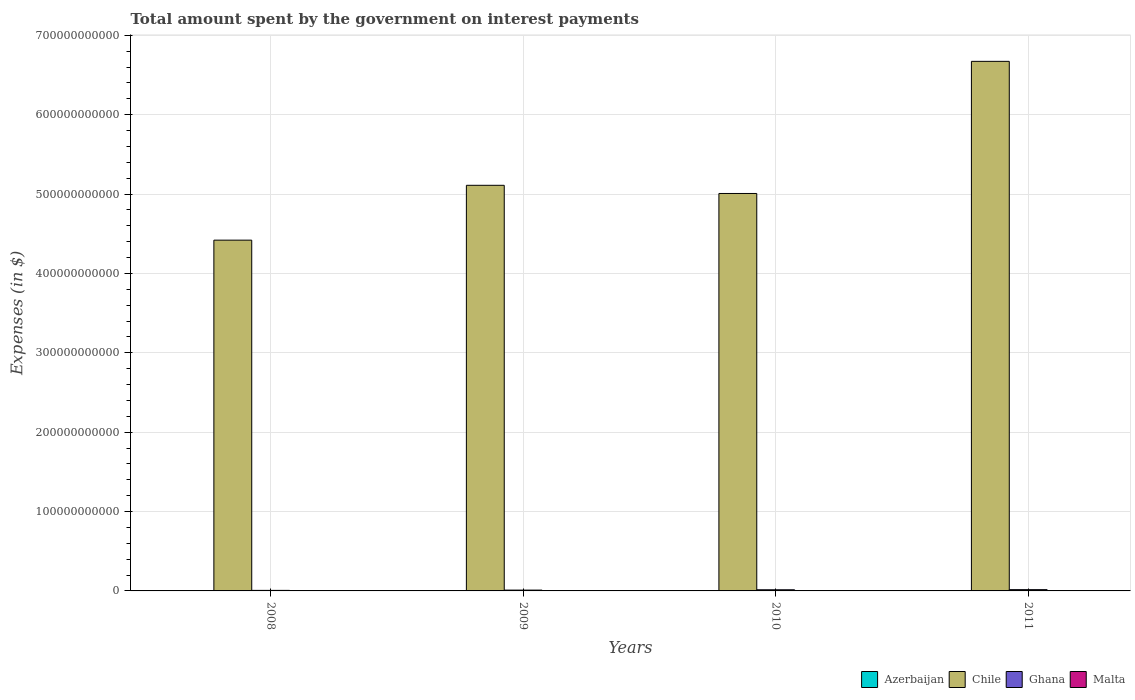How many different coloured bars are there?
Provide a succinct answer. 4. How many groups of bars are there?
Your answer should be very brief. 4. How many bars are there on the 2nd tick from the right?
Offer a terse response. 4. What is the amount spent on interest payments by the government in Chile in 2010?
Your answer should be compact. 5.01e+11. Across all years, what is the maximum amount spent on interest payments by the government in Ghana?
Your answer should be very brief. 1.61e+09. Across all years, what is the minimum amount spent on interest payments by the government in Ghana?
Offer a terse response. 6.79e+08. What is the total amount spent on interest payments by the government in Azerbaijan in the graph?
Offer a very short reply. 3.20e+08. What is the difference between the amount spent on interest payments by the government in Ghana in 2008 and that in 2009?
Make the answer very short. -3.53e+08. What is the difference between the amount spent on interest payments by the government in Ghana in 2008 and the amount spent on interest payments by the government in Malta in 2009?
Keep it short and to the point. 4.96e+08. What is the average amount spent on interest payments by the government in Malta per year?
Offer a terse response. 1.89e+08. In the year 2008, what is the difference between the amount spent on interest payments by the government in Chile and amount spent on interest payments by the government in Malta?
Your answer should be compact. 4.42e+11. In how many years, is the amount spent on interest payments by the government in Azerbaijan greater than 240000000000 $?
Offer a very short reply. 0. What is the ratio of the amount spent on interest payments by the government in Azerbaijan in 2008 to that in 2011?
Provide a succinct answer. 0.19. Is the difference between the amount spent on interest payments by the government in Chile in 2008 and 2011 greater than the difference between the amount spent on interest payments by the government in Malta in 2008 and 2011?
Provide a short and direct response. No. What is the difference between the highest and the second highest amount spent on interest payments by the government in Ghana?
Provide a succinct answer. 1.72e+08. What is the difference between the highest and the lowest amount spent on interest payments by the government in Malta?
Keep it short and to the point. 1.75e+07. What does the 2nd bar from the right in 2011 represents?
Your answer should be compact. Ghana. How many bars are there?
Your answer should be compact. 16. Are all the bars in the graph horizontal?
Your answer should be very brief. No. How many years are there in the graph?
Offer a terse response. 4. What is the difference between two consecutive major ticks on the Y-axis?
Your response must be concise. 1.00e+11. Does the graph contain grids?
Provide a succinct answer. Yes. Where does the legend appear in the graph?
Ensure brevity in your answer.  Bottom right. What is the title of the graph?
Your response must be concise. Total amount spent by the government on interest payments. Does "Lao PDR" appear as one of the legend labels in the graph?
Ensure brevity in your answer.  No. What is the label or title of the Y-axis?
Ensure brevity in your answer.  Expenses (in $). What is the Expenses (in $) of Azerbaijan in 2008?
Your answer should be very brief. 3.27e+07. What is the Expenses (in $) of Chile in 2008?
Offer a very short reply. 4.42e+11. What is the Expenses (in $) in Ghana in 2008?
Give a very brief answer. 6.79e+08. What is the Expenses (in $) in Malta in 2008?
Make the answer very short. 1.88e+08. What is the Expenses (in $) in Azerbaijan in 2009?
Offer a very short reply. 7.87e+07. What is the Expenses (in $) of Chile in 2009?
Offer a very short reply. 5.11e+11. What is the Expenses (in $) of Ghana in 2009?
Your answer should be compact. 1.03e+09. What is the Expenses (in $) in Malta in 2009?
Provide a short and direct response. 1.83e+08. What is the Expenses (in $) of Azerbaijan in 2010?
Keep it short and to the point. 3.95e+07. What is the Expenses (in $) of Chile in 2010?
Provide a short and direct response. 5.01e+11. What is the Expenses (in $) of Ghana in 2010?
Keep it short and to the point. 1.44e+09. What is the Expenses (in $) of Malta in 2010?
Your response must be concise. 1.86e+08. What is the Expenses (in $) of Azerbaijan in 2011?
Offer a very short reply. 1.70e+08. What is the Expenses (in $) of Chile in 2011?
Your answer should be compact. 6.67e+11. What is the Expenses (in $) of Ghana in 2011?
Your answer should be very brief. 1.61e+09. What is the Expenses (in $) of Malta in 2011?
Provide a succinct answer. 2.01e+08. Across all years, what is the maximum Expenses (in $) in Azerbaijan?
Keep it short and to the point. 1.70e+08. Across all years, what is the maximum Expenses (in $) in Chile?
Your response must be concise. 6.67e+11. Across all years, what is the maximum Expenses (in $) of Ghana?
Your answer should be very brief. 1.61e+09. Across all years, what is the maximum Expenses (in $) of Malta?
Make the answer very short. 2.01e+08. Across all years, what is the minimum Expenses (in $) in Azerbaijan?
Provide a succinct answer. 3.27e+07. Across all years, what is the minimum Expenses (in $) in Chile?
Your answer should be very brief. 4.42e+11. Across all years, what is the minimum Expenses (in $) of Ghana?
Make the answer very short. 6.79e+08. Across all years, what is the minimum Expenses (in $) of Malta?
Keep it short and to the point. 1.83e+08. What is the total Expenses (in $) in Azerbaijan in the graph?
Give a very brief answer. 3.20e+08. What is the total Expenses (in $) in Chile in the graph?
Offer a terse response. 2.12e+12. What is the total Expenses (in $) of Ghana in the graph?
Make the answer very short. 4.76e+09. What is the total Expenses (in $) in Malta in the graph?
Provide a succinct answer. 7.58e+08. What is the difference between the Expenses (in $) of Azerbaijan in 2008 and that in 2009?
Make the answer very short. -4.60e+07. What is the difference between the Expenses (in $) of Chile in 2008 and that in 2009?
Your answer should be compact. -6.91e+1. What is the difference between the Expenses (in $) of Ghana in 2008 and that in 2009?
Provide a succinct answer. -3.53e+08. What is the difference between the Expenses (in $) in Malta in 2008 and that in 2009?
Give a very brief answer. 4.39e+06. What is the difference between the Expenses (in $) of Azerbaijan in 2008 and that in 2010?
Provide a succinct answer. -6.80e+06. What is the difference between the Expenses (in $) of Chile in 2008 and that in 2010?
Provide a succinct answer. -5.88e+1. What is the difference between the Expenses (in $) of Ghana in 2008 and that in 2010?
Provide a short and direct response. -7.60e+08. What is the difference between the Expenses (in $) of Malta in 2008 and that in 2010?
Ensure brevity in your answer.  1.37e+06. What is the difference between the Expenses (in $) in Azerbaijan in 2008 and that in 2011?
Your response must be concise. -1.37e+08. What is the difference between the Expenses (in $) of Chile in 2008 and that in 2011?
Provide a short and direct response. -2.25e+11. What is the difference between the Expenses (in $) of Ghana in 2008 and that in 2011?
Make the answer very short. -9.32e+08. What is the difference between the Expenses (in $) in Malta in 2008 and that in 2011?
Your response must be concise. -1.31e+07. What is the difference between the Expenses (in $) in Azerbaijan in 2009 and that in 2010?
Offer a very short reply. 3.92e+07. What is the difference between the Expenses (in $) in Chile in 2009 and that in 2010?
Your answer should be compact. 1.03e+1. What is the difference between the Expenses (in $) in Ghana in 2009 and that in 2010?
Ensure brevity in your answer.  -4.07e+08. What is the difference between the Expenses (in $) in Malta in 2009 and that in 2010?
Ensure brevity in your answer.  -3.02e+06. What is the difference between the Expenses (in $) of Azerbaijan in 2009 and that in 2011?
Your answer should be very brief. -9.09e+07. What is the difference between the Expenses (in $) in Chile in 2009 and that in 2011?
Your answer should be very brief. -1.56e+11. What is the difference between the Expenses (in $) in Ghana in 2009 and that in 2011?
Make the answer very short. -5.79e+08. What is the difference between the Expenses (in $) in Malta in 2009 and that in 2011?
Offer a terse response. -1.75e+07. What is the difference between the Expenses (in $) in Azerbaijan in 2010 and that in 2011?
Keep it short and to the point. -1.30e+08. What is the difference between the Expenses (in $) in Chile in 2010 and that in 2011?
Keep it short and to the point. -1.66e+11. What is the difference between the Expenses (in $) of Ghana in 2010 and that in 2011?
Give a very brief answer. -1.72e+08. What is the difference between the Expenses (in $) of Malta in 2010 and that in 2011?
Provide a short and direct response. -1.45e+07. What is the difference between the Expenses (in $) in Azerbaijan in 2008 and the Expenses (in $) in Chile in 2009?
Provide a short and direct response. -5.11e+11. What is the difference between the Expenses (in $) of Azerbaijan in 2008 and the Expenses (in $) of Ghana in 2009?
Provide a succinct answer. -1.00e+09. What is the difference between the Expenses (in $) in Azerbaijan in 2008 and the Expenses (in $) in Malta in 2009?
Your answer should be very brief. -1.51e+08. What is the difference between the Expenses (in $) of Chile in 2008 and the Expenses (in $) of Ghana in 2009?
Provide a short and direct response. 4.41e+11. What is the difference between the Expenses (in $) in Chile in 2008 and the Expenses (in $) in Malta in 2009?
Offer a terse response. 4.42e+11. What is the difference between the Expenses (in $) of Ghana in 2008 and the Expenses (in $) of Malta in 2009?
Provide a succinct answer. 4.96e+08. What is the difference between the Expenses (in $) of Azerbaijan in 2008 and the Expenses (in $) of Chile in 2010?
Offer a terse response. -5.01e+11. What is the difference between the Expenses (in $) of Azerbaijan in 2008 and the Expenses (in $) of Ghana in 2010?
Give a very brief answer. -1.41e+09. What is the difference between the Expenses (in $) in Azerbaijan in 2008 and the Expenses (in $) in Malta in 2010?
Provide a succinct answer. -1.54e+08. What is the difference between the Expenses (in $) of Chile in 2008 and the Expenses (in $) of Ghana in 2010?
Provide a short and direct response. 4.40e+11. What is the difference between the Expenses (in $) of Chile in 2008 and the Expenses (in $) of Malta in 2010?
Keep it short and to the point. 4.42e+11. What is the difference between the Expenses (in $) of Ghana in 2008 and the Expenses (in $) of Malta in 2010?
Your response must be concise. 4.93e+08. What is the difference between the Expenses (in $) of Azerbaijan in 2008 and the Expenses (in $) of Chile in 2011?
Your answer should be very brief. -6.67e+11. What is the difference between the Expenses (in $) of Azerbaijan in 2008 and the Expenses (in $) of Ghana in 2011?
Your response must be concise. -1.58e+09. What is the difference between the Expenses (in $) in Azerbaijan in 2008 and the Expenses (in $) in Malta in 2011?
Make the answer very short. -1.68e+08. What is the difference between the Expenses (in $) of Chile in 2008 and the Expenses (in $) of Ghana in 2011?
Keep it short and to the point. 4.40e+11. What is the difference between the Expenses (in $) of Chile in 2008 and the Expenses (in $) of Malta in 2011?
Your answer should be very brief. 4.42e+11. What is the difference between the Expenses (in $) of Ghana in 2008 and the Expenses (in $) of Malta in 2011?
Provide a short and direct response. 4.78e+08. What is the difference between the Expenses (in $) of Azerbaijan in 2009 and the Expenses (in $) of Chile in 2010?
Keep it short and to the point. -5.01e+11. What is the difference between the Expenses (in $) of Azerbaijan in 2009 and the Expenses (in $) of Ghana in 2010?
Keep it short and to the point. -1.36e+09. What is the difference between the Expenses (in $) in Azerbaijan in 2009 and the Expenses (in $) in Malta in 2010?
Your response must be concise. -1.08e+08. What is the difference between the Expenses (in $) of Chile in 2009 and the Expenses (in $) of Ghana in 2010?
Make the answer very short. 5.10e+11. What is the difference between the Expenses (in $) of Chile in 2009 and the Expenses (in $) of Malta in 2010?
Give a very brief answer. 5.11e+11. What is the difference between the Expenses (in $) in Ghana in 2009 and the Expenses (in $) in Malta in 2010?
Ensure brevity in your answer.  8.46e+08. What is the difference between the Expenses (in $) of Azerbaijan in 2009 and the Expenses (in $) of Chile in 2011?
Your answer should be very brief. -6.67e+11. What is the difference between the Expenses (in $) in Azerbaijan in 2009 and the Expenses (in $) in Ghana in 2011?
Ensure brevity in your answer.  -1.53e+09. What is the difference between the Expenses (in $) of Azerbaijan in 2009 and the Expenses (in $) of Malta in 2011?
Your response must be concise. -1.22e+08. What is the difference between the Expenses (in $) of Chile in 2009 and the Expenses (in $) of Ghana in 2011?
Your answer should be very brief. 5.09e+11. What is the difference between the Expenses (in $) in Chile in 2009 and the Expenses (in $) in Malta in 2011?
Your response must be concise. 5.11e+11. What is the difference between the Expenses (in $) in Ghana in 2009 and the Expenses (in $) in Malta in 2011?
Give a very brief answer. 8.32e+08. What is the difference between the Expenses (in $) of Azerbaijan in 2010 and the Expenses (in $) of Chile in 2011?
Give a very brief answer. -6.67e+11. What is the difference between the Expenses (in $) in Azerbaijan in 2010 and the Expenses (in $) in Ghana in 2011?
Offer a very short reply. -1.57e+09. What is the difference between the Expenses (in $) of Azerbaijan in 2010 and the Expenses (in $) of Malta in 2011?
Ensure brevity in your answer.  -1.61e+08. What is the difference between the Expenses (in $) of Chile in 2010 and the Expenses (in $) of Ghana in 2011?
Your answer should be compact. 4.99e+11. What is the difference between the Expenses (in $) in Chile in 2010 and the Expenses (in $) in Malta in 2011?
Provide a short and direct response. 5.01e+11. What is the difference between the Expenses (in $) in Ghana in 2010 and the Expenses (in $) in Malta in 2011?
Provide a succinct answer. 1.24e+09. What is the average Expenses (in $) of Azerbaijan per year?
Keep it short and to the point. 8.01e+07. What is the average Expenses (in $) in Chile per year?
Keep it short and to the point. 5.30e+11. What is the average Expenses (in $) in Ghana per year?
Your response must be concise. 1.19e+09. What is the average Expenses (in $) in Malta per year?
Provide a short and direct response. 1.89e+08. In the year 2008, what is the difference between the Expenses (in $) of Azerbaijan and Expenses (in $) of Chile?
Your response must be concise. -4.42e+11. In the year 2008, what is the difference between the Expenses (in $) of Azerbaijan and Expenses (in $) of Ghana?
Provide a succinct answer. -6.46e+08. In the year 2008, what is the difference between the Expenses (in $) in Azerbaijan and Expenses (in $) in Malta?
Offer a terse response. -1.55e+08. In the year 2008, what is the difference between the Expenses (in $) in Chile and Expenses (in $) in Ghana?
Your response must be concise. 4.41e+11. In the year 2008, what is the difference between the Expenses (in $) of Chile and Expenses (in $) of Malta?
Ensure brevity in your answer.  4.42e+11. In the year 2008, what is the difference between the Expenses (in $) in Ghana and Expenses (in $) in Malta?
Your answer should be very brief. 4.92e+08. In the year 2009, what is the difference between the Expenses (in $) of Azerbaijan and Expenses (in $) of Chile?
Your response must be concise. -5.11e+11. In the year 2009, what is the difference between the Expenses (in $) of Azerbaijan and Expenses (in $) of Ghana?
Give a very brief answer. -9.54e+08. In the year 2009, what is the difference between the Expenses (in $) in Azerbaijan and Expenses (in $) in Malta?
Your answer should be compact. -1.05e+08. In the year 2009, what is the difference between the Expenses (in $) of Chile and Expenses (in $) of Ghana?
Make the answer very short. 5.10e+11. In the year 2009, what is the difference between the Expenses (in $) in Chile and Expenses (in $) in Malta?
Give a very brief answer. 5.11e+11. In the year 2009, what is the difference between the Expenses (in $) of Ghana and Expenses (in $) of Malta?
Ensure brevity in your answer.  8.49e+08. In the year 2010, what is the difference between the Expenses (in $) in Azerbaijan and Expenses (in $) in Chile?
Offer a very short reply. -5.01e+11. In the year 2010, what is the difference between the Expenses (in $) of Azerbaijan and Expenses (in $) of Ghana?
Keep it short and to the point. -1.40e+09. In the year 2010, what is the difference between the Expenses (in $) in Azerbaijan and Expenses (in $) in Malta?
Your answer should be very brief. -1.47e+08. In the year 2010, what is the difference between the Expenses (in $) in Chile and Expenses (in $) in Ghana?
Keep it short and to the point. 4.99e+11. In the year 2010, what is the difference between the Expenses (in $) of Chile and Expenses (in $) of Malta?
Offer a very short reply. 5.01e+11. In the year 2010, what is the difference between the Expenses (in $) in Ghana and Expenses (in $) in Malta?
Keep it short and to the point. 1.25e+09. In the year 2011, what is the difference between the Expenses (in $) in Azerbaijan and Expenses (in $) in Chile?
Provide a succinct answer. -6.67e+11. In the year 2011, what is the difference between the Expenses (in $) in Azerbaijan and Expenses (in $) in Ghana?
Your answer should be compact. -1.44e+09. In the year 2011, what is the difference between the Expenses (in $) of Azerbaijan and Expenses (in $) of Malta?
Your answer should be very brief. -3.12e+07. In the year 2011, what is the difference between the Expenses (in $) in Chile and Expenses (in $) in Ghana?
Ensure brevity in your answer.  6.66e+11. In the year 2011, what is the difference between the Expenses (in $) in Chile and Expenses (in $) in Malta?
Offer a terse response. 6.67e+11. In the year 2011, what is the difference between the Expenses (in $) of Ghana and Expenses (in $) of Malta?
Make the answer very short. 1.41e+09. What is the ratio of the Expenses (in $) of Azerbaijan in 2008 to that in 2009?
Your answer should be very brief. 0.42. What is the ratio of the Expenses (in $) in Chile in 2008 to that in 2009?
Keep it short and to the point. 0.86. What is the ratio of the Expenses (in $) in Ghana in 2008 to that in 2009?
Your response must be concise. 0.66. What is the ratio of the Expenses (in $) of Azerbaijan in 2008 to that in 2010?
Provide a succinct answer. 0.83. What is the ratio of the Expenses (in $) in Chile in 2008 to that in 2010?
Offer a very short reply. 0.88. What is the ratio of the Expenses (in $) in Ghana in 2008 to that in 2010?
Offer a terse response. 0.47. What is the ratio of the Expenses (in $) of Malta in 2008 to that in 2010?
Keep it short and to the point. 1.01. What is the ratio of the Expenses (in $) of Azerbaijan in 2008 to that in 2011?
Provide a succinct answer. 0.19. What is the ratio of the Expenses (in $) in Chile in 2008 to that in 2011?
Your answer should be compact. 0.66. What is the ratio of the Expenses (in $) of Ghana in 2008 to that in 2011?
Your answer should be very brief. 0.42. What is the ratio of the Expenses (in $) of Malta in 2008 to that in 2011?
Your answer should be compact. 0.93. What is the ratio of the Expenses (in $) of Azerbaijan in 2009 to that in 2010?
Provide a succinct answer. 1.99. What is the ratio of the Expenses (in $) of Chile in 2009 to that in 2010?
Offer a very short reply. 1.02. What is the ratio of the Expenses (in $) of Ghana in 2009 to that in 2010?
Make the answer very short. 0.72. What is the ratio of the Expenses (in $) in Malta in 2009 to that in 2010?
Give a very brief answer. 0.98. What is the ratio of the Expenses (in $) in Azerbaijan in 2009 to that in 2011?
Give a very brief answer. 0.46. What is the ratio of the Expenses (in $) in Chile in 2009 to that in 2011?
Your answer should be very brief. 0.77. What is the ratio of the Expenses (in $) in Ghana in 2009 to that in 2011?
Offer a terse response. 0.64. What is the ratio of the Expenses (in $) in Malta in 2009 to that in 2011?
Provide a short and direct response. 0.91. What is the ratio of the Expenses (in $) in Azerbaijan in 2010 to that in 2011?
Ensure brevity in your answer.  0.23. What is the ratio of the Expenses (in $) of Chile in 2010 to that in 2011?
Provide a short and direct response. 0.75. What is the ratio of the Expenses (in $) in Ghana in 2010 to that in 2011?
Offer a very short reply. 0.89. What is the ratio of the Expenses (in $) in Malta in 2010 to that in 2011?
Provide a succinct answer. 0.93. What is the difference between the highest and the second highest Expenses (in $) in Azerbaijan?
Provide a short and direct response. 9.09e+07. What is the difference between the highest and the second highest Expenses (in $) of Chile?
Provide a succinct answer. 1.56e+11. What is the difference between the highest and the second highest Expenses (in $) in Ghana?
Offer a very short reply. 1.72e+08. What is the difference between the highest and the second highest Expenses (in $) of Malta?
Offer a very short reply. 1.31e+07. What is the difference between the highest and the lowest Expenses (in $) in Azerbaijan?
Provide a succinct answer. 1.37e+08. What is the difference between the highest and the lowest Expenses (in $) in Chile?
Your response must be concise. 2.25e+11. What is the difference between the highest and the lowest Expenses (in $) of Ghana?
Offer a very short reply. 9.32e+08. What is the difference between the highest and the lowest Expenses (in $) of Malta?
Your answer should be very brief. 1.75e+07. 